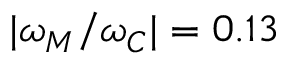<formula> <loc_0><loc_0><loc_500><loc_500>| \omega _ { M } / \omega _ { C } | = 0 . 1 3</formula> 